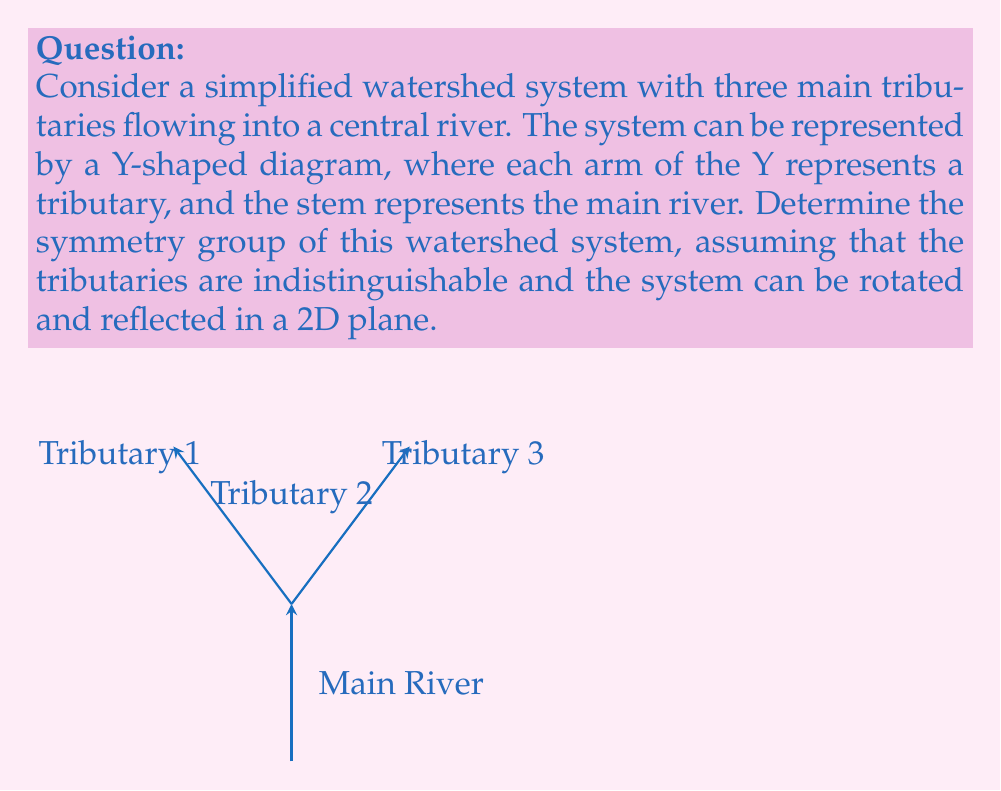Teach me how to tackle this problem. To determine the symmetry group of this watershed system, we need to identify all the symmetry operations that leave the system unchanged. Let's approach this step-by-step:

1. Rotational symmetry:
   The system has a 120° rotational symmetry. We can rotate the diagram by 120° or 240° clockwise or counterclockwise, and it will look the same. This gives us three rotational symmetries: the identity (0° rotation), 120° rotation, and 240° rotation.

2. Reflection symmetry:
   The system has three lines of reflection symmetry, each passing through one tributary and bisecting the angle between the other two.

3. Counting the symmetries:
   - 1 identity operation
   - 2 non-identity rotations (120° and 240°)
   - 3 reflections

   In total, we have 6 symmetry operations.

4. Group structure:
   These symmetries form a group under composition. The structure of this group is identical to the symmetries of an equilateral triangle.

5. Identifying the group:
   This group is known as the dihedral group of order 6, denoted as $D_3$ or $D_6$ (depending on the notation system used).

6. Group properties:
   - The group is non-abelian (rotations and reflections don't commute).
   - It has 6 elements.
   - It can be generated by a rotation of 120° and a single reflection.

7. Group presentation:
   The group can be presented as:
   $D_3 = \langle r, s \mid r^3 = s^2 = 1, srs = r^{-1} \rangle$
   where $r$ represents a 120° rotation and $s$ represents a reflection.

Therefore, the symmetry group of this watershed system is isomorphic to the dihedral group $D_3$ (or $D_6$).
Answer: The symmetry group of the watershed system is $D_3$ (or $D_6$), the dihedral group of order 6. 